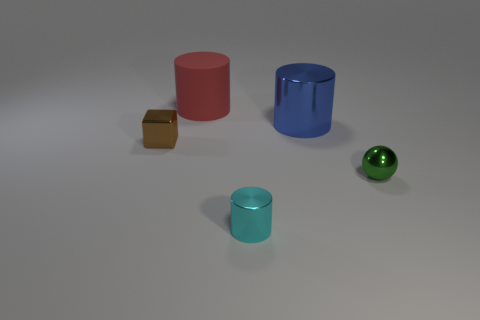Add 1 green metallic balls. How many objects exist? 6 Subtract all large yellow things. Subtract all tiny shiny objects. How many objects are left? 2 Add 4 brown metallic things. How many brown metallic things are left? 5 Add 3 small things. How many small things exist? 6 Subtract 0 red blocks. How many objects are left? 5 Subtract all cylinders. How many objects are left? 2 